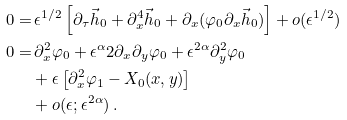<formula> <loc_0><loc_0><loc_500><loc_500>0 = & \, \epsilon ^ { 1 / 2 } \left [ \partial _ { \tau } \vec { h } _ { 0 } + \partial _ { x } ^ { 4 } \vec { h } _ { 0 } + \partial _ { x } ( \varphi _ { 0 } \partial _ { x } \vec { h } _ { 0 } ) \right ] + o ( \epsilon ^ { 1 / 2 } ) \\ 0 = & \, \partial _ { x } ^ { 2 } \varphi _ { 0 } + \epsilon ^ { \alpha } 2 \partial _ { x } \partial _ { y } \varphi _ { 0 } + \epsilon ^ { 2 \alpha } \partial _ { y } ^ { 2 } \varphi _ { 0 } \\ & + \epsilon \left [ \partial _ { x } ^ { 2 } \varphi _ { 1 } - X _ { 0 } ( x , y ) \right ] \\ & + o ( \epsilon ; \epsilon ^ { 2 \alpha } ) \, .</formula> 